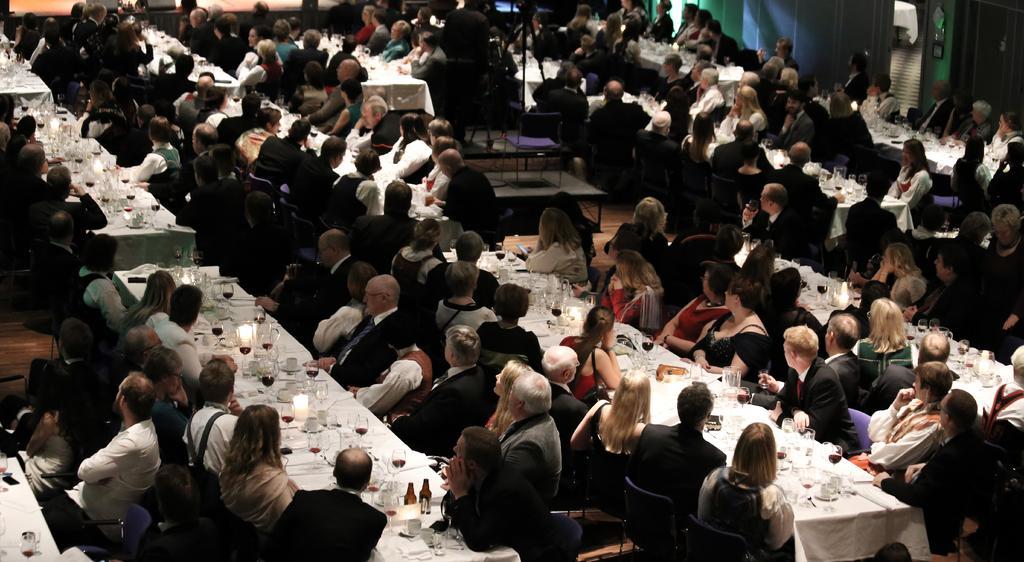Please provide a concise description of this image. This is a big hall in which everybody is sitting in front of a table in their chairs. On the table, there are some glasses, jars and some plates here. There are men and women in this room. 